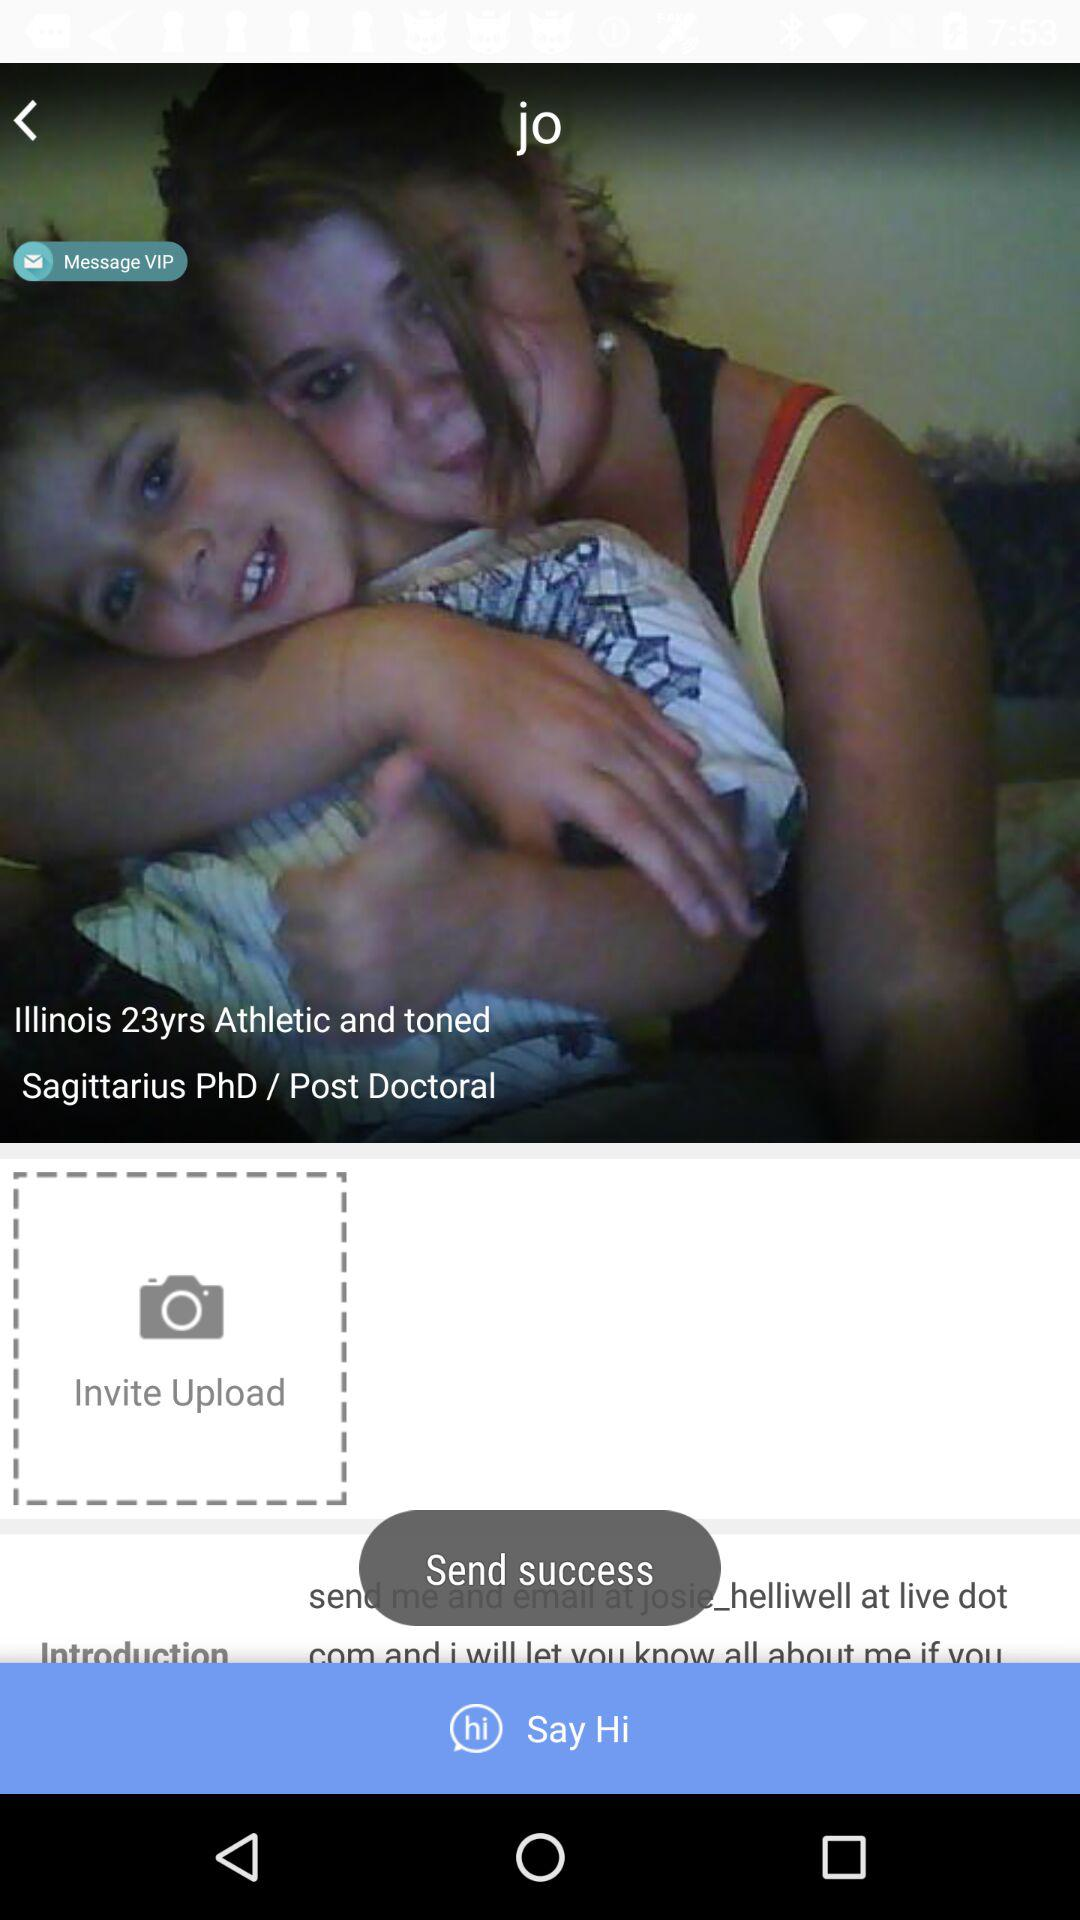What is the age? The age is 23 years. 